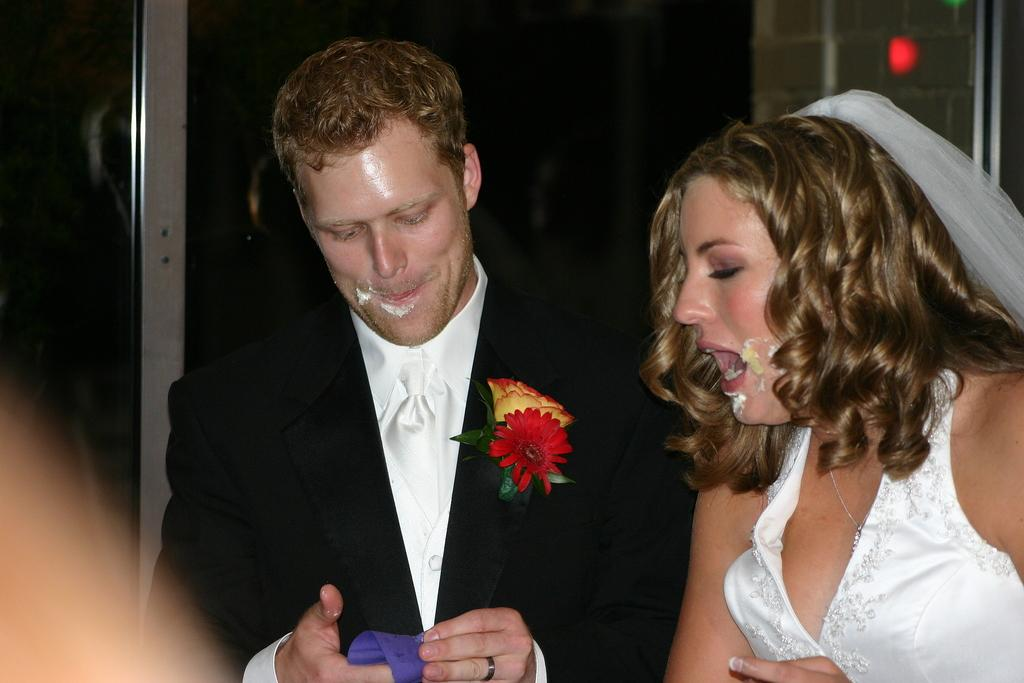How many people are in the image? There are two people in the image, a man and a woman. What are the man and woman wearing? The man is wearing a black coat, and the woman is wearing a white dress. What can be observed about the background of the image? The background of the image is dark. What is the rate of the cabbage growing in the image? There is no cabbage present in the image, so it is not possible to determine its growth rate. 